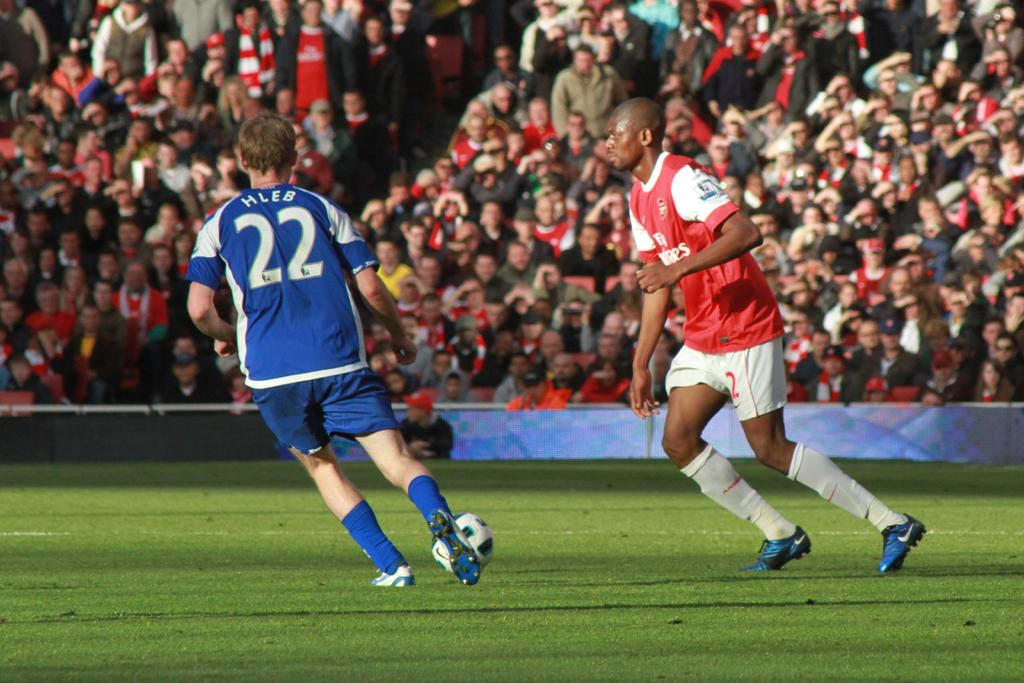How many people are in the image? There are two men in the image. What are the men doing in the image? The men are standing on the ground and have a football. Are there any other people in the image besides the two men? Yes, there are people in front of the men. What are the people in front of the men doing? The people are looking at the men. What type of book is the man holding in the image? There is no book present in the image; the men have a football. 